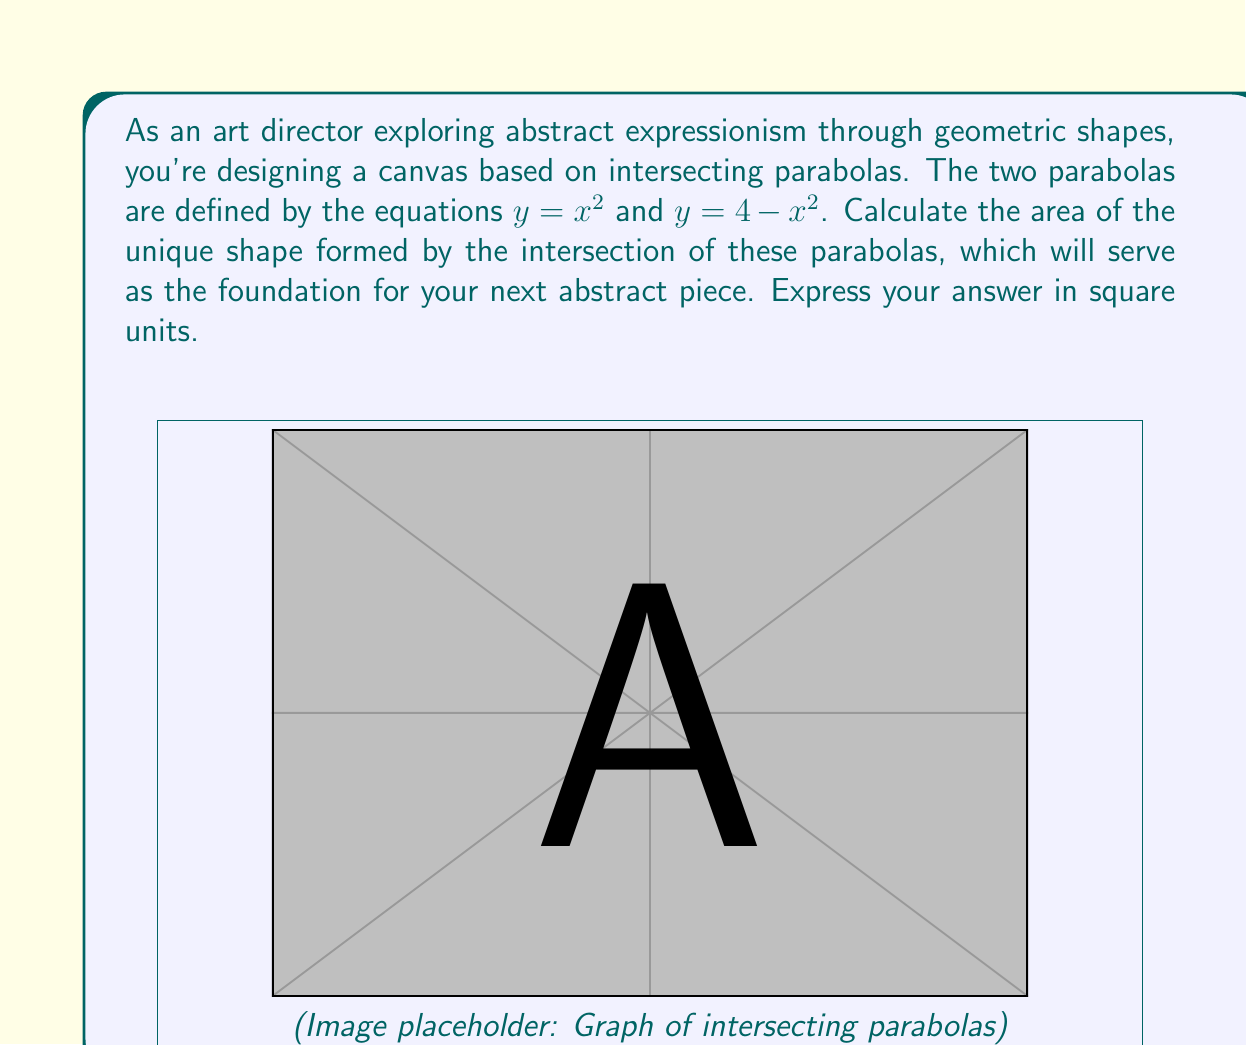What is the answer to this math problem? Let's approach this step-by-step:

1) First, we need to find the points of intersection of the two parabolas. We can do this by setting the equations equal to each other:

   $x^2 = 4 - x^2$

2) Solving this equation:
   $2x^2 = 4$
   $x^2 = 2$
   $x = \pm\sqrt{2}$

   So the parabolas intersect at $(-\sqrt{2}, 2)$ and $(\sqrt{2}, 2)$.

3) The area we're looking for is the area between the two curves from $x = -\sqrt{2}$ to $x = \sqrt{2}$.

4) We can calculate this area by integrating the difference between the upper curve ($y = 4 - x^2$) and the lower curve ($y = x^2$) over this interval:

   $$ \text{Area} = \int_{-\sqrt{2}}^{\sqrt{2}} [(4-x^2) - x^2] dx $$

5) Simplifying the integrand:
   $$ \text{Area} = \int_{-\sqrt{2}}^{\sqrt{2}} (4 - 2x^2) dx $$

6) Integrating:
   $$ \text{Area} = [4x - \frac{2x^3}{3}]_{-\sqrt{2}}^{\sqrt{2}} $$

7) Evaluating the integral:
   $$ \text{Area} = (4\sqrt{2} - \frac{2(\sqrt{2})^3}{3}) - (-4\sqrt{2} - \frac{2(-\sqrt{2})^3}{3}) $$
   $$ = (4\sqrt{2} - \frac{4\sqrt{2}}{3}) + (4\sqrt{2} + \frac{4\sqrt{2}}{3}) $$
   $$ = 8\sqrt{2} $$

8) Therefore, the area of the shape formed by the intersecting parabolas is $8\sqrt{2}$ square units.
Answer: $8\sqrt{2}$ square units 